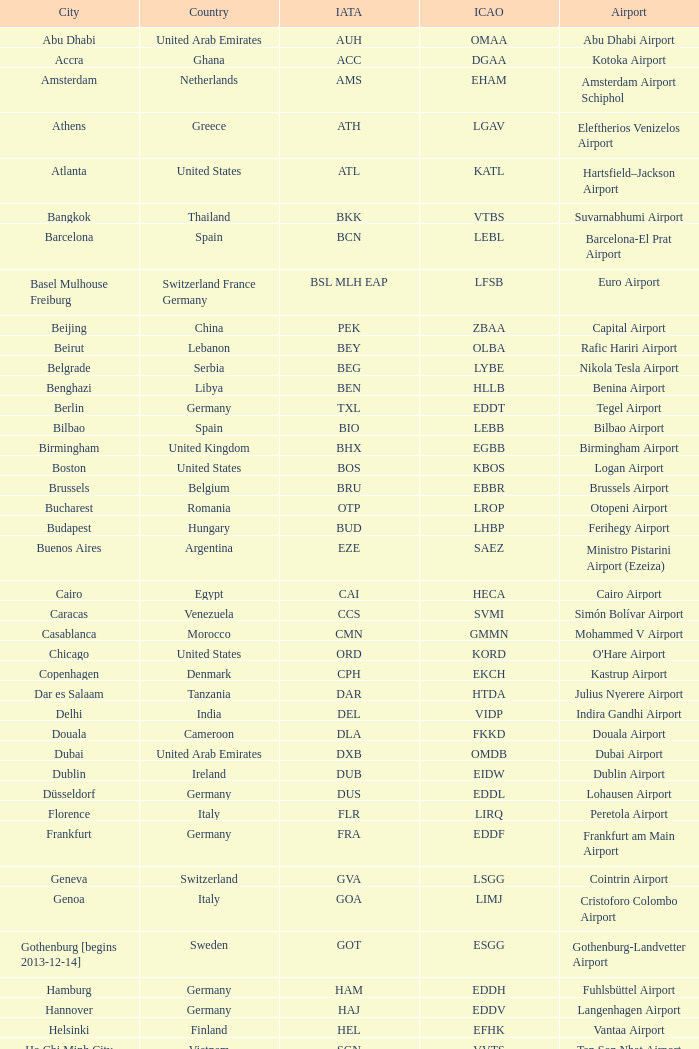What city is fuhlsbüttel airport in? Hamburg. 